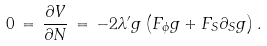Convert formula to latex. <formula><loc_0><loc_0><loc_500><loc_500>0 \, = \, \frac { \partial V } { \partial N } \, = \, - 2 \lambda ^ { \prime } g \left ( F _ { \phi } g + F _ { S } \partial _ { S } g \right ) .</formula> 